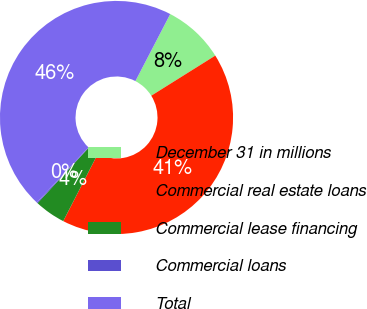Convert chart. <chart><loc_0><loc_0><loc_500><loc_500><pie_chart><fcel>December 31 in millions<fcel>Commercial real estate loans<fcel>Commercial lease financing<fcel>Commercial loans<fcel>Total<nl><fcel>8.47%<fcel>41.47%<fcel>4.3%<fcel>0.13%<fcel>45.64%<nl></chart> 